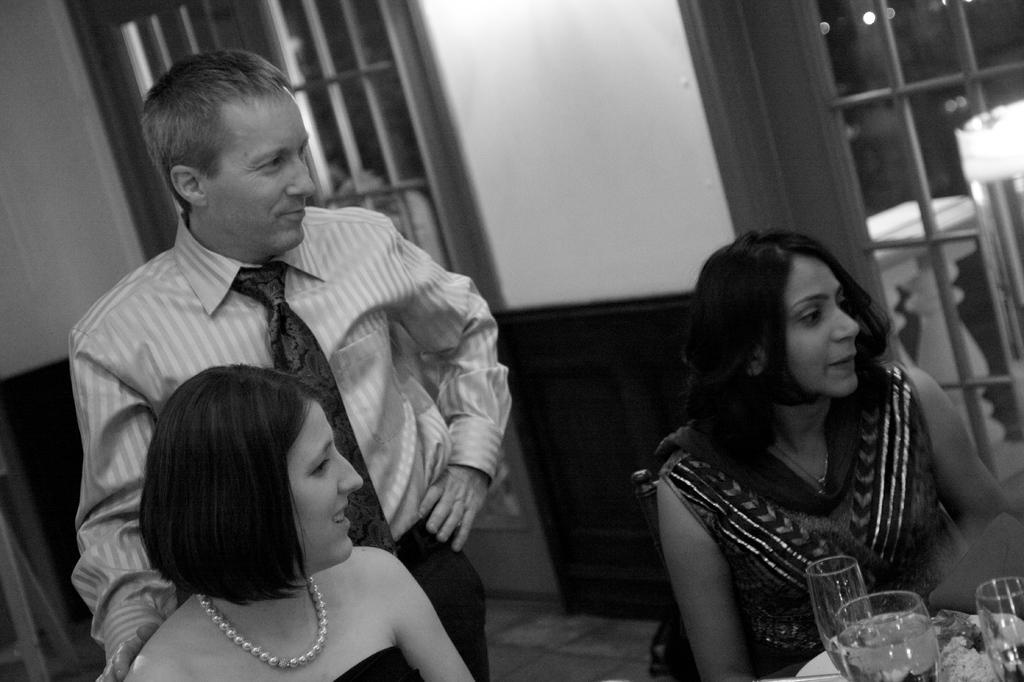In one or two sentences, can you explain what this image depicts? There is a black and white image. In this image, there are two persons wearing clothes and sitting in front of the table contains glasses. There is person on the left side of the image standing and wearing clothes. 